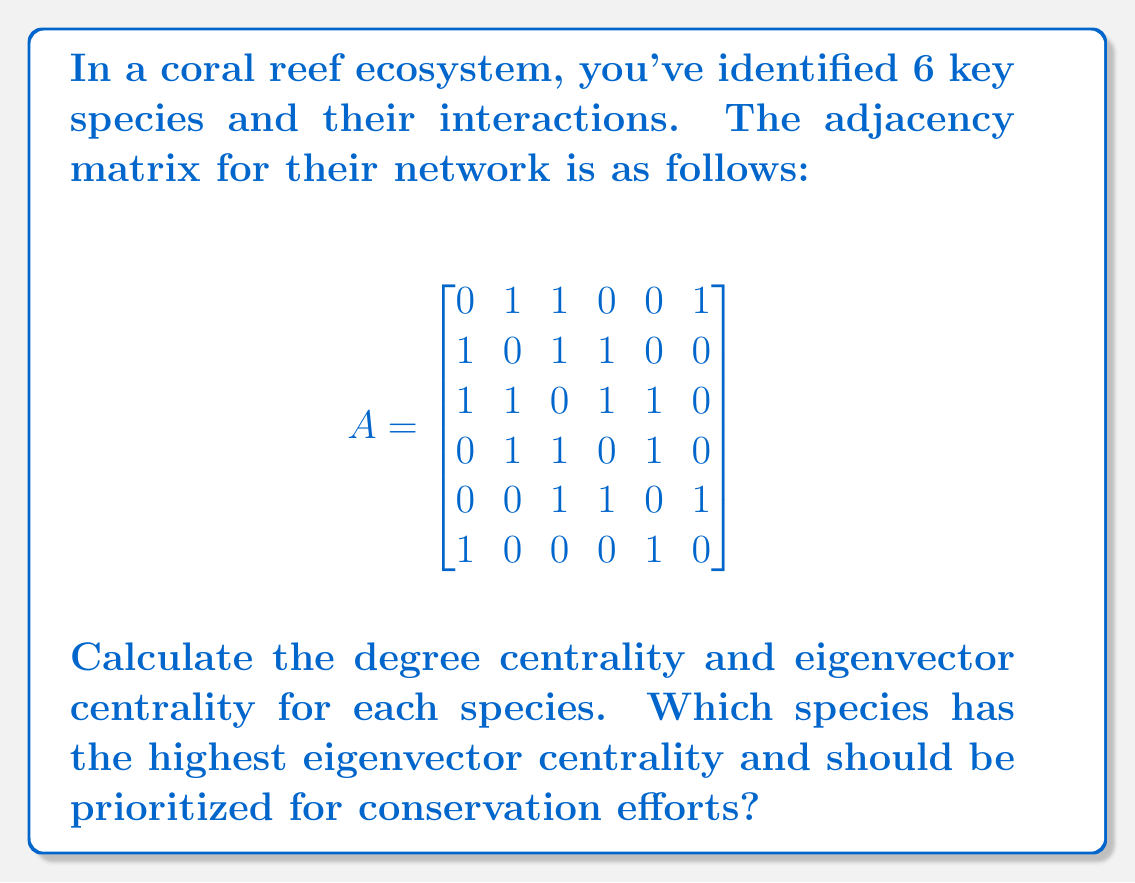Solve this math problem. To solve this problem, we'll calculate both degree centrality and eigenvector centrality for each species in the coral reef network.

1. Degree Centrality:
   Degree centrality is simply the number of connections each node has. We can calculate this by summing each row (or column, as the matrix is symmetric) of the adjacency matrix.

   Species 1: 3
   Species 2: 3
   Species 3: 4
   Species 4: 3
   Species 5: 3
   Species 6: 2

2. Eigenvector Centrality:
   Eigenvector centrality is calculated using the principal eigenvector of the adjacency matrix. We need to find the eigenvector corresponding to the largest eigenvalue.

   First, we calculate the eigenvalues:
   
   $$\det(A - \lambda I) = 0$$
   
   Solving this equation gives us the largest eigenvalue: $\lambda_{max} \approx 2.4815$

   Next, we solve $(A - \lambda_{max}I)x = 0$ to find the corresponding eigenvector:

   $$
   \begin{bmatrix}
   -2.4815 & 1 & 1 & 0 & 0 & 1 \\
   1 & -2.4815 & 1 & 1 & 0 & 0 \\
   1 & 1 & -2.4815 & 1 & 1 & 0 \\
   0 & 1 & 1 & -2.4815 & 1 & 0 \\
   0 & 0 & 1 & 1 & -2.4815 & 1 \\
   1 & 0 & 0 & 0 & 1 & -2.4815
   \end{bmatrix}
   \begin{bmatrix}
   x_1 \\ x_2 \\ x_3 \\ x_4 \\ x_5 \\ x_6
   \end{bmatrix}
   = \begin{bmatrix}
   0 \\ 0 \\ 0 \\ 0 \\ 0 \\ 0
   \end{bmatrix}
   $$

   Solving this system and normalizing the result, we get the eigenvector centralities:

   Species 1: 0.3906
   Species 2: 0.4303
   Species 3: 0.5160
   Species 4: 0.4303
   Species 5: 0.3906
   Species 6: 0.2415

Species 3 has the highest eigenvector centrality (0.5160), indicating it is the most central and influential species in the network.
Answer: Species 3 has the highest eigenvector centrality (0.5160) and should be prioritized for conservation efforts. 